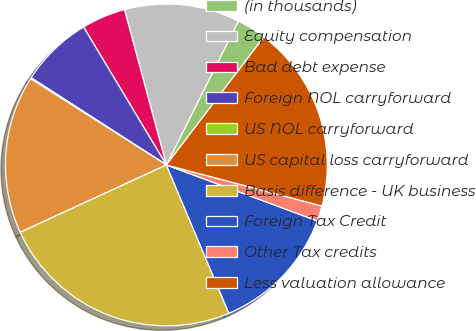<chart> <loc_0><loc_0><loc_500><loc_500><pie_chart><fcel>(in thousands)<fcel>Equity compensation<fcel>Bad debt expense<fcel>Foreign NOL carryforward<fcel>US NOL carryforward<fcel>US capital loss carryforward<fcel>Basis difference - UK business<fcel>Foreign Tax Credit<fcel>Other Tax credits<fcel>Less valuation allowance<nl><fcel>2.98%<fcel>11.58%<fcel>4.41%<fcel>7.28%<fcel>0.11%<fcel>15.88%<fcel>24.48%<fcel>13.01%<fcel>1.54%<fcel>18.75%<nl></chart> 